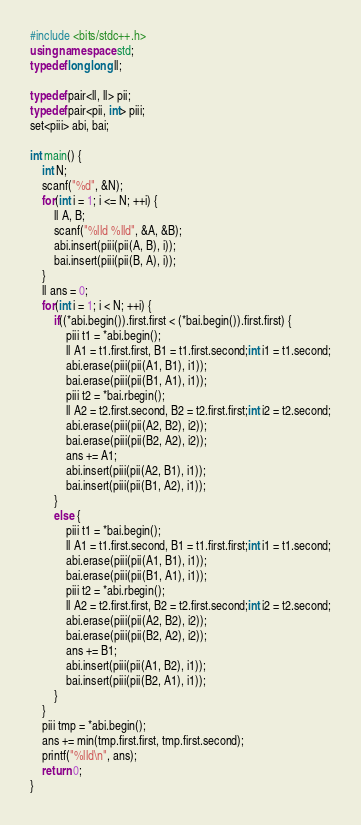<code> <loc_0><loc_0><loc_500><loc_500><_C++_>#include <bits/stdc++.h>
using namespace std;
typedef long long ll;

typedef pair<ll, ll> pii;
typedef pair<pii, int> piii;
set<piii> abi, bai;

int main() {
    int N;
    scanf("%d", &N);
    for(int i = 1; i <= N; ++i) {
        ll A, B;
        scanf("%lld %lld", &A, &B);
        abi.insert(piii(pii(A, B), i));
        bai.insert(piii(pii(B, A), i));
    }
    ll ans = 0;
    for(int i = 1; i < N; ++i) {
        if((*abi.begin()).first.first < (*bai.begin()).first.first) {
            piii t1 = *abi.begin();
            ll A1 = t1.first.first, B1 = t1.first.second;int i1 = t1.second;
            abi.erase(piii(pii(A1, B1), i1));
            bai.erase(piii(pii(B1, A1), i1));
            piii t2 = *bai.rbegin();
            ll A2 = t2.first.second, B2 = t2.first.first;int i2 = t2.second;
            abi.erase(piii(pii(A2, B2), i2));
            bai.erase(piii(pii(B2, A2), i2));
            ans += A1;
            abi.insert(piii(pii(A2, B1), i1));
            bai.insert(piii(pii(B1, A2), i1));
        }
        else {
            piii t1 = *bai.begin();
            ll A1 = t1.first.second, B1 = t1.first.first;int i1 = t1.second;
            abi.erase(piii(pii(A1, B1), i1));
            bai.erase(piii(pii(B1, A1), i1));
            piii t2 = *abi.rbegin();
            ll A2 = t2.first.first, B2 = t2.first.second;int i2 = t2.second;
            abi.erase(piii(pii(A2, B2), i2));
            bai.erase(piii(pii(B2, A2), i2));
            ans += B1;
            abi.insert(piii(pii(A1, B2), i1));
            bai.insert(piii(pii(B2, A1), i1));
        }
    }
    piii tmp = *abi.begin();
    ans += min(tmp.first.first, tmp.first.second);
    printf("%lld\n", ans);
    return 0;
}</code> 